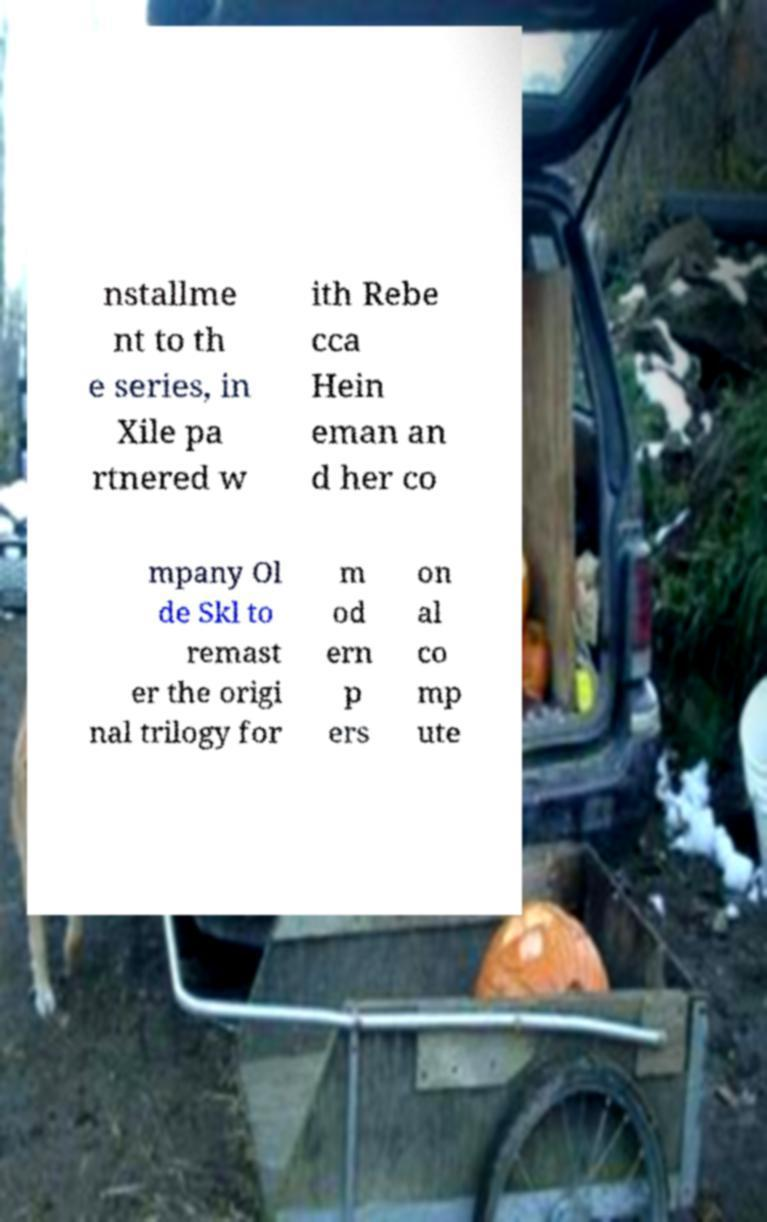For documentation purposes, I need the text within this image transcribed. Could you provide that? nstallme nt to th e series, in Xile pa rtnered w ith Rebe cca Hein eman an d her co mpany Ol de Skl to remast er the origi nal trilogy for m od ern p ers on al co mp ute 